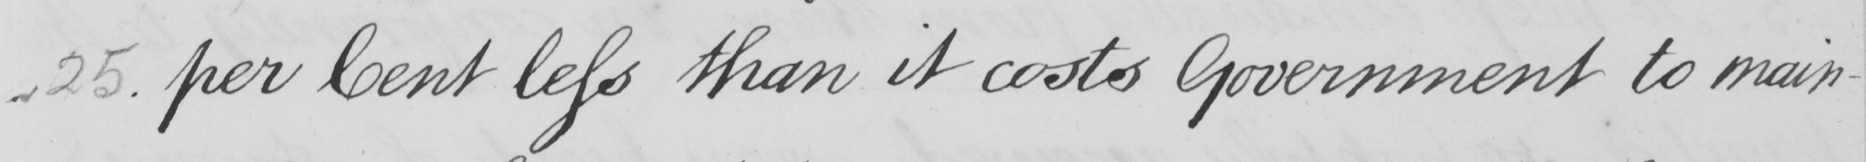Can you read and transcribe this handwriting? 25 . per Cent less than it costs Government to main- 